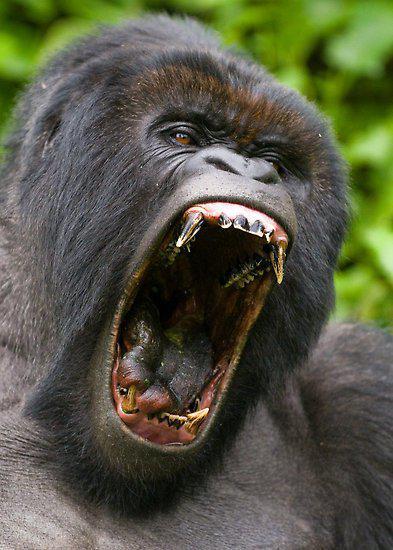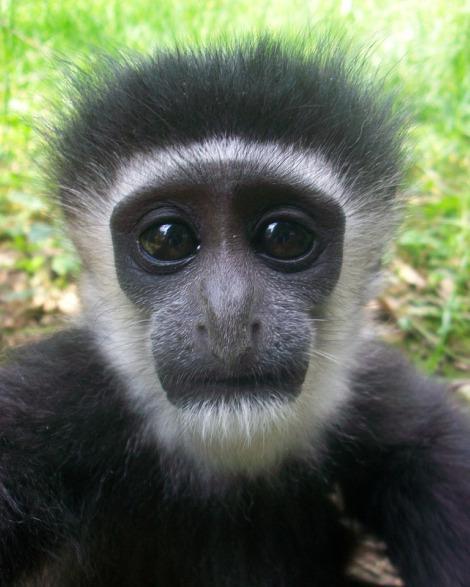The first image is the image on the left, the second image is the image on the right. For the images shown, is this caption "In one of the image there is a baby gorilla next to an adult gorilla." true? Answer yes or no. No. The first image is the image on the left, the second image is the image on the right. Analyze the images presented: Is the assertion "At least one image has a gorilla with an open mouth." valid? Answer yes or no. Yes. 